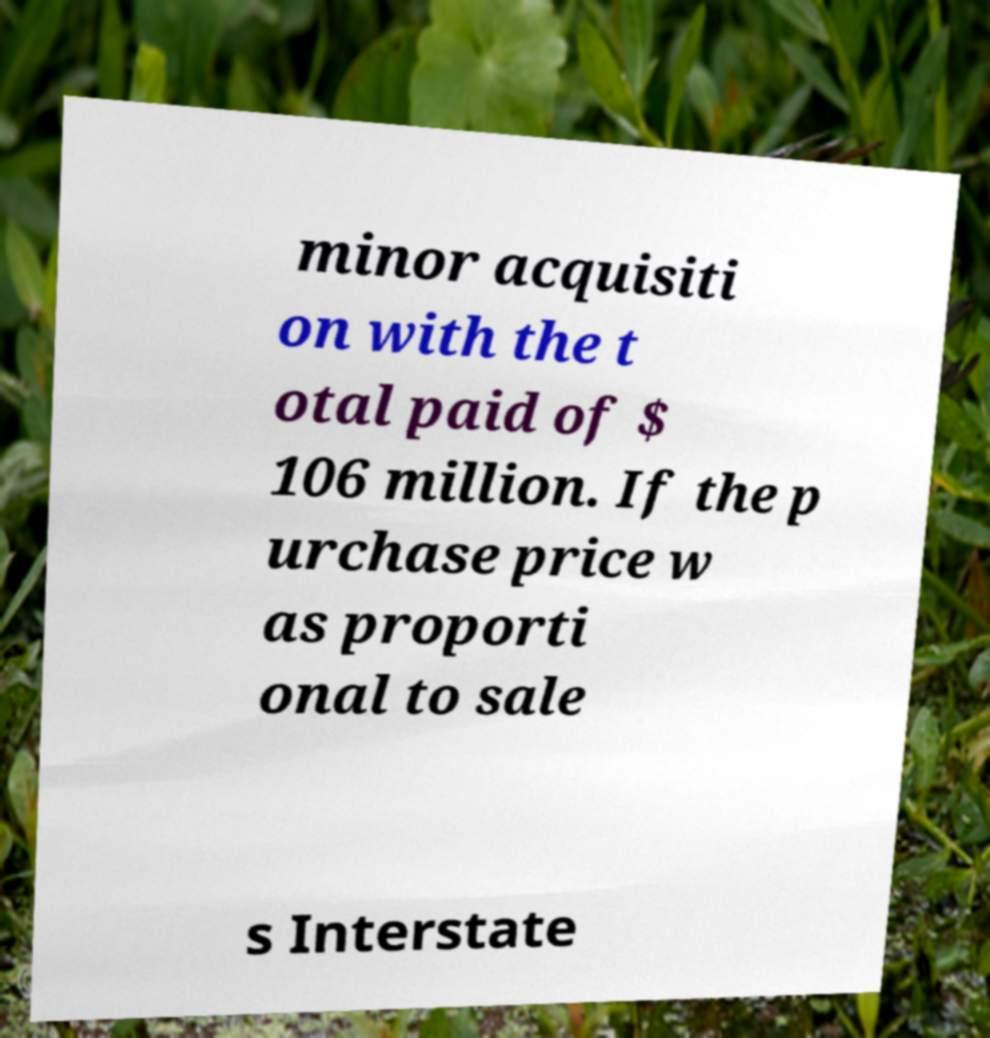Could you extract and type out the text from this image? minor acquisiti on with the t otal paid of $ 106 million. If the p urchase price w as proporti onal to sale s Interstate 